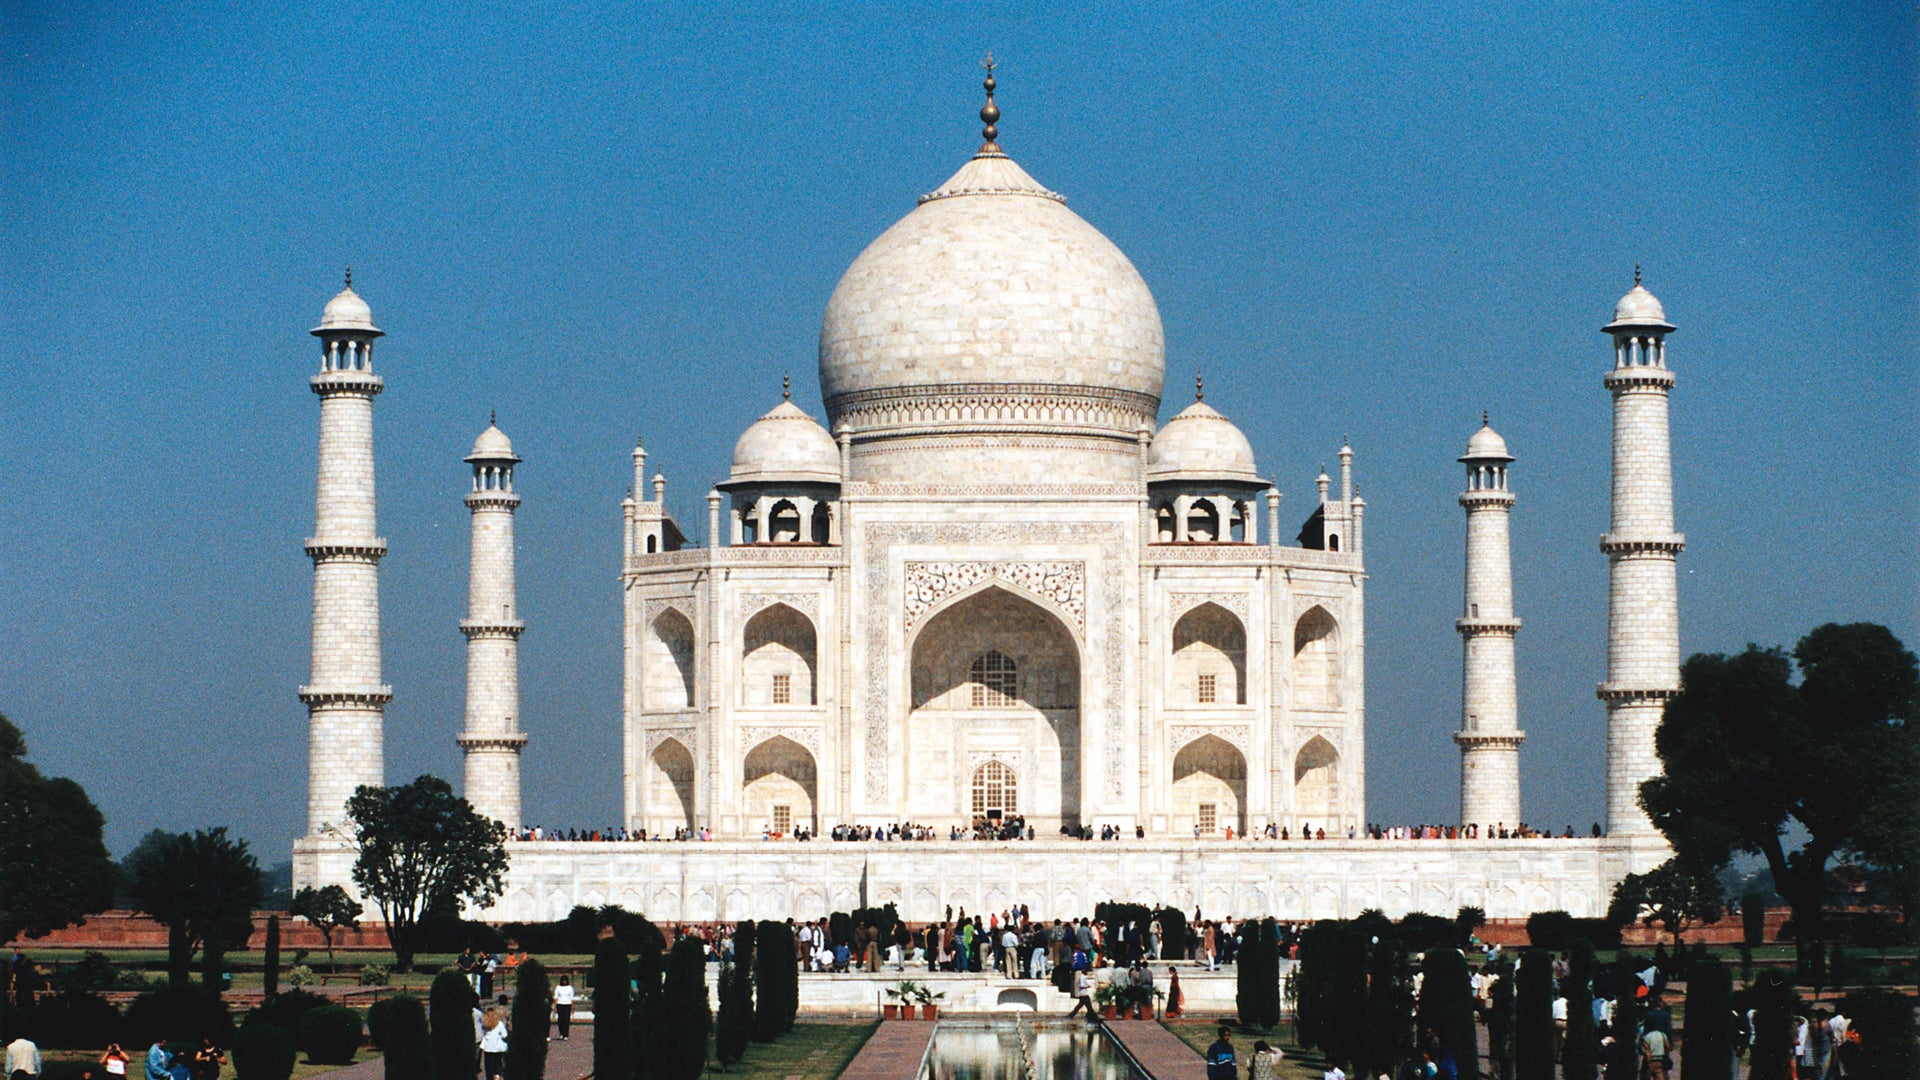Can you describe the main features of this image for me? The image captures the majestic Taj Mahal, a renowned mausoleum located in Agra, India. The Taj Mahal, a marvel of white marble, stands tall against the backdrop of a clear blue sky. Its grandeur is accentuated by a large central dome and four slender minarets that grace its corners. The perspective of the image is such that it encapsulates the entire structure, offering a distant view that underscores its imposing presence. The Taj Mahal's reflection dances on the surface of the water body in front of it, creating a mirror image that adds to the visual appeal. The surrounding area is speckled with verdant trees and a scattering of people, adding life to the scene. The image is a testament to the architectural brilliance and historical significance of this world-famous landmark. 